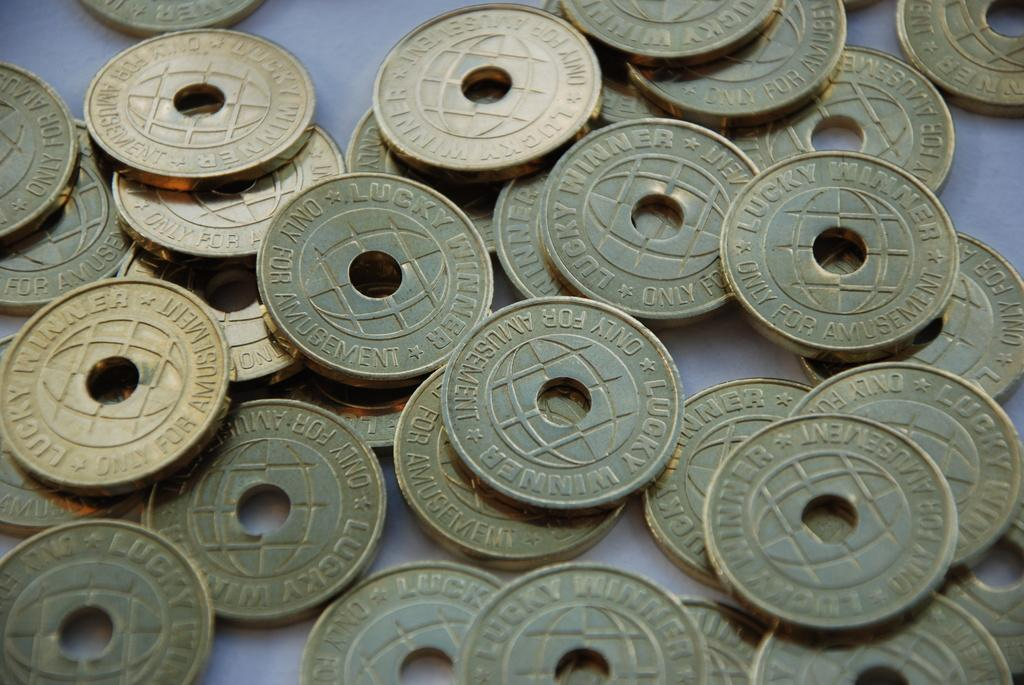<image>
Describe the image concisely. Multiple gold plated lucky winner amusement coins laying on a table. 